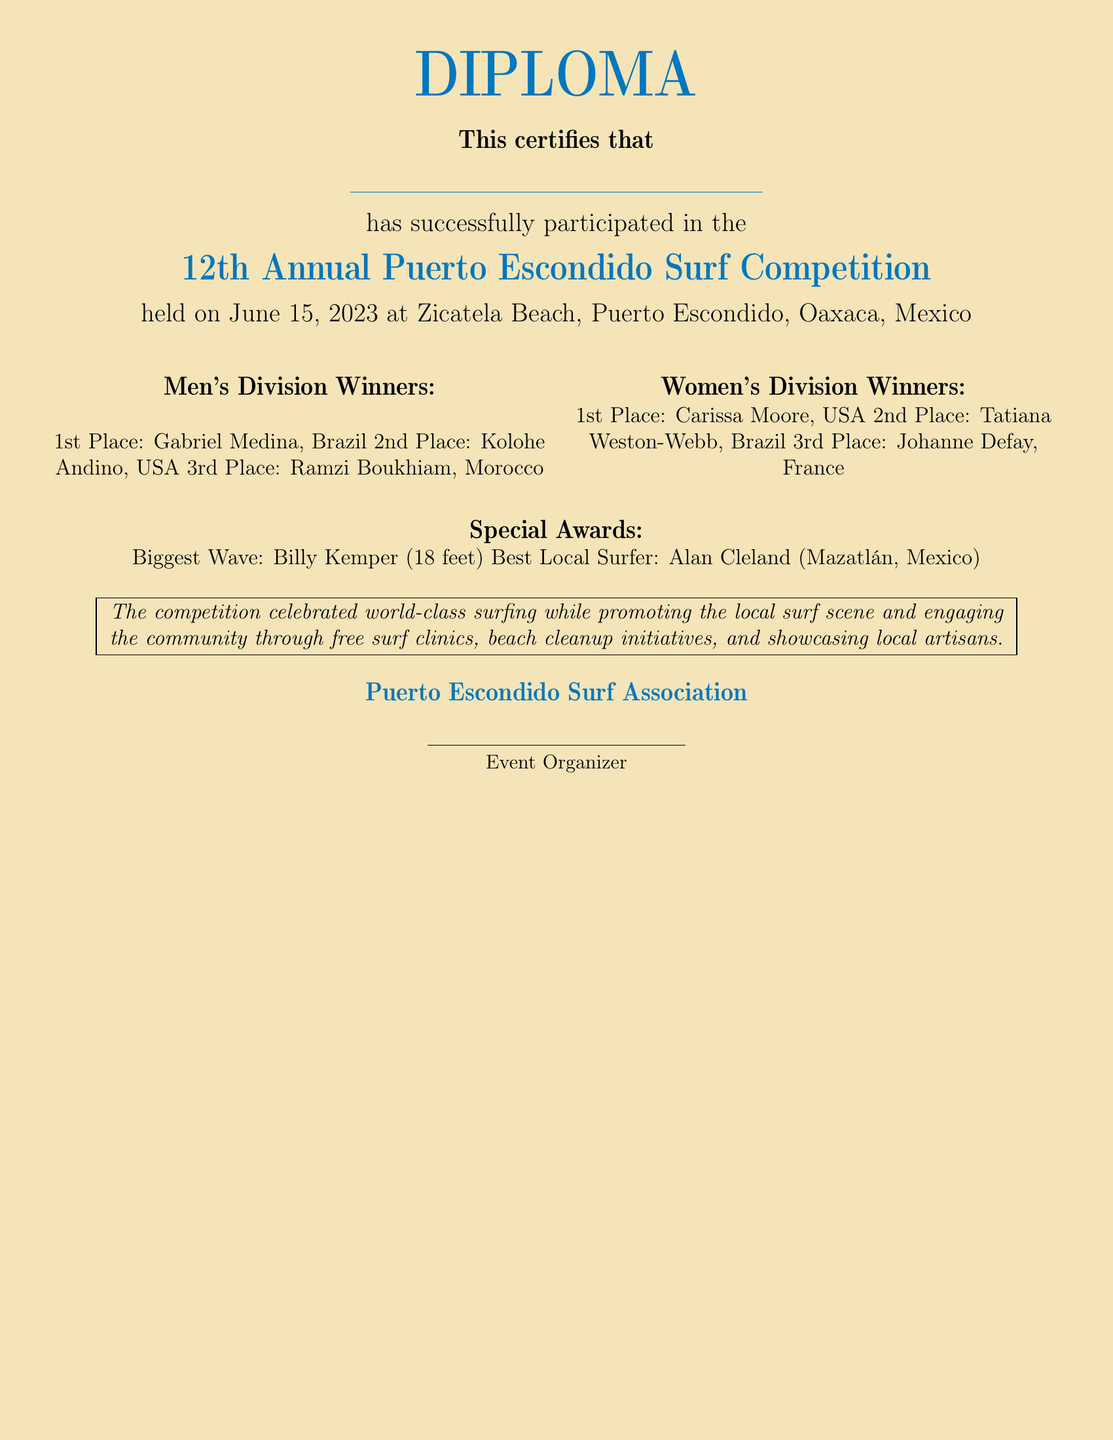What date was the competition held? The date is explicitly mentioned in the document as June 15, 2023.
Answer: June 15, 2023 Who won 1st place in the Men's Division? The document lists Gabriel Medina as the 1st place winner in the Men's Division.
Answer: Gabriel Medina How many places were awarded in the Women's Division? The document states 3 places were awarded in the Women's Division.
Answer: 3 Who received the Biggest Wave award? The text specifies that Billy Kemper received the Biggest Wave award.
Answer: Billy Kemper What height was the Biggest Wave? The document states that the Biggest Wave measured 18 feet.
Answer: 18 feet Which local surfer received a special award? Alan Cleland is mentioned as the Best Local Surfer in the document.
Answer: Alan Cleland What is the main purpose of the competition as mentioned? The document highlights that the competition promotes the local surf scene and engages the community.
Answer: To promote the local surf scene How many players were mentioned in the Men's Division winners? The winners' list includes 3 players in the Men's Division.
Answer: 3 Who organized the event? The document indicates that the Puerto Escondido Surf Association organized the event.
Answer: Puerto Escondido Surf Association 